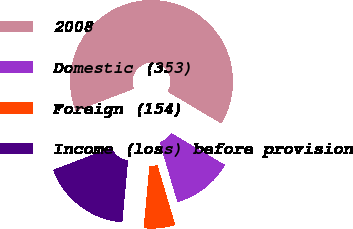Convert chart to OTSL. <chart><loc_0><loc_0><loc_500><loc_500><pie_chart><fcel>2008<fcel>Domestic (353)<fcel>Foreign (154)<fcel>Income (loss) before provision<nl><fcel>64.33%<fcel>11.89%<fcel>6.06%<fcel>17.72%<nl></chart> 